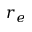Convert formula to latex. <formula><loc_0><loc_0><loc_500><loc_500>r _ { e }</formula> 